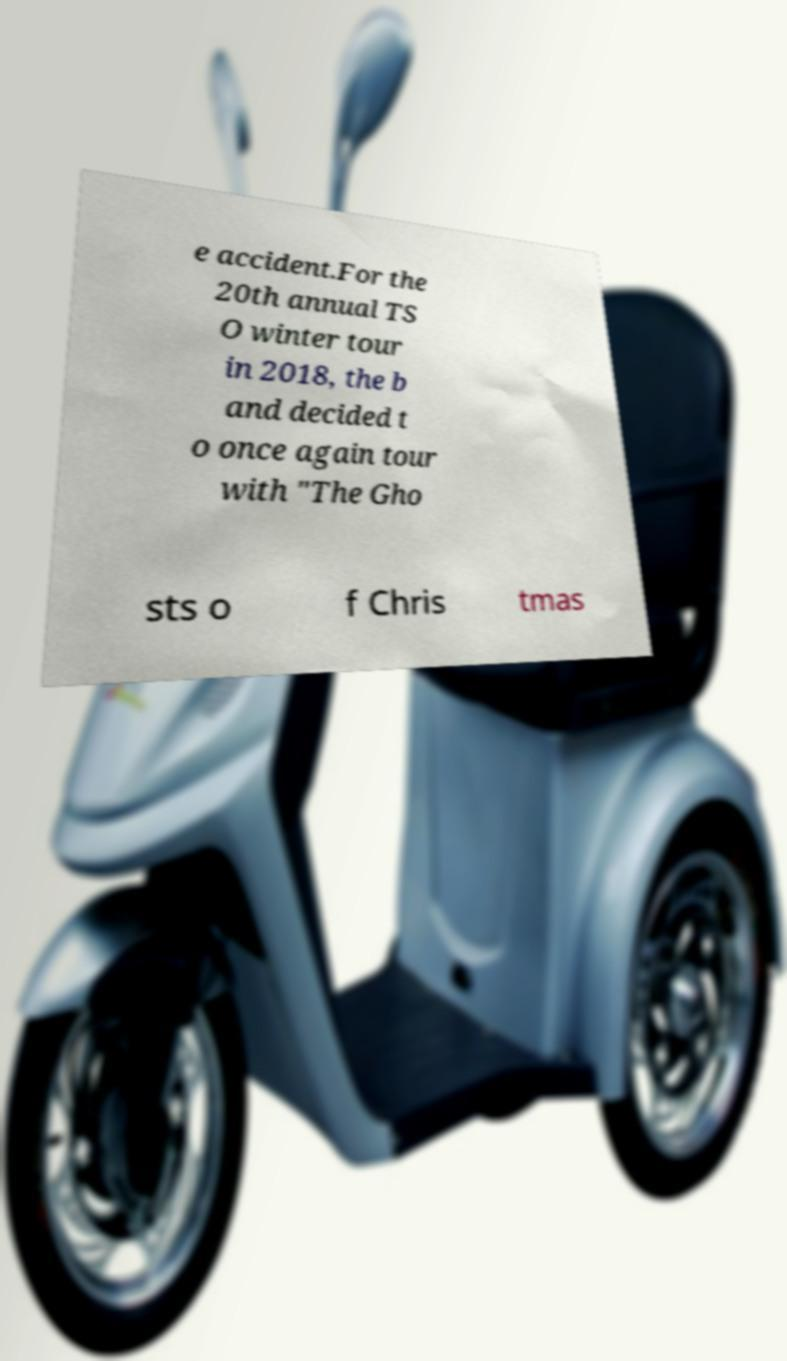Can you read and provide the text displayed in the image?This photo seems to have some interesting text. Can you extract and type it out for me? e accident.For the 20th annual TS O winter tour in 2018, the b and decided t o once again tour with "The Gho sts o f Chris tmas 